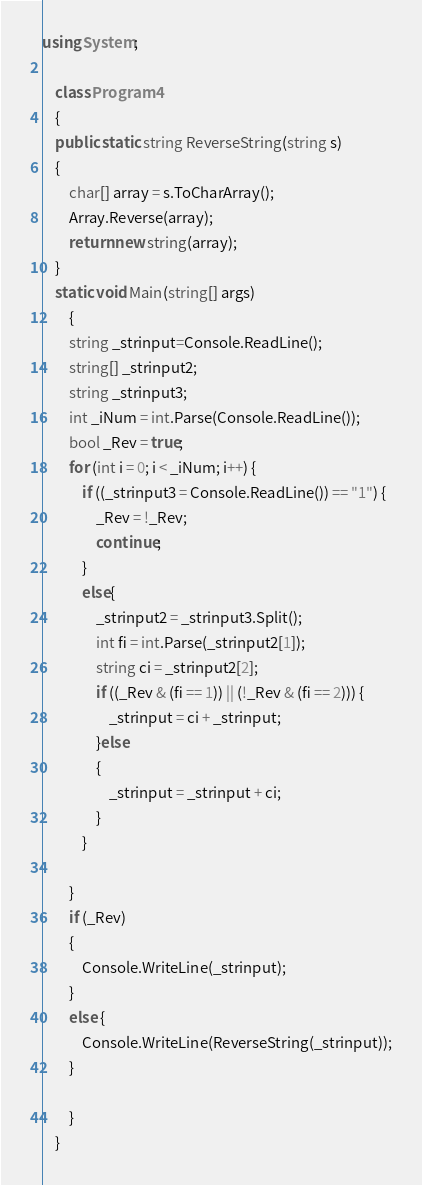<code> <loc_0><loc_0><loc_500><loc_500><_C#_>using System;

    class Program4
    {
    public static string ReverseString(string s)
    {
        char[] array = s.ToCharArray();
        Array.Reverse(array);
        return new string(array);
    }
    static void Main(string[] args)
        {
        string _strinput=Console.ReadLine();
        string[] _strinput2;
        string _strinput3;
        int _iNum = int.Parse(Console.ReadLine());
        bool _Rev = true;
        for (int i = 0; i < _iNum; i++) {
            if ((_strinput3 = Console.ReadLine()) == "1") {
                _Rev = !_Rev;
                continue;
            }
            else{
                _strinput2 = _strinput3.Split();
                int fi = int.Parse(_strinput2[1]);
                string ci = _strinput2[2];
                if ((_Rev & (fi == 1)) || (!_Rev & (fi == 2))) {
                    _strinput = ci + _strinput;
                }else
                {
                    _strinput = _strinput + ci;
                }
            }

        }
        if (_Rev)
        {
            Console.WriteLine(_strinput);
        }
        else {
            Console.WriteLine(ReverseString(_strinput));
        }
            
        }
    }

</code> 